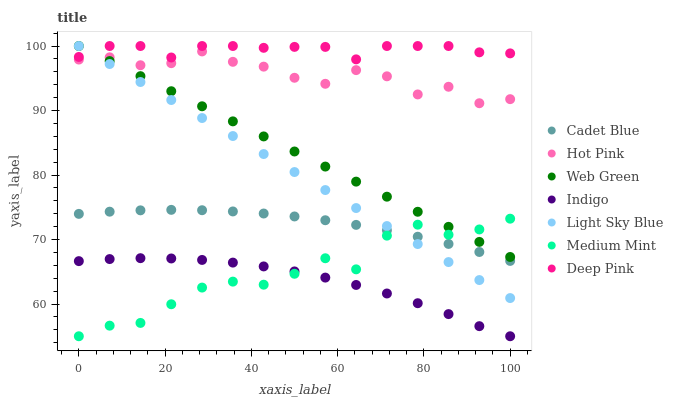Does Indigo have the minimum area under the curve?
Answer yes or no. Yes. Does Deep Pink have the maximum area under the curve?
Answer yes or no. Yes. Does Cadet Blue have the minimum area under the curve?
Answer yes or no. No. Does Cadet Blue have the maximum area under the curve?
Answer yes or no. No. Is Web Green the smoothest?
Answer yes or no. Yes. Is Medium Mint the roughest?
Answer yes or no. Yes. Is Cadet Blue the smoothest?
Answer yes or no. No. Is Cadet Blue the roughest?
Answer yes or no. No. Does Medium Mint have the lowest value?
Answer yes or no. Yes. Does Cadet Blue have the lowest value?
Answer yes or no. No. Does Light Sky Blue have the highest value?
Answer yes or no. Yes. Does Cadet Blue have the highest value?
Answer yes or no. No. Is Indigo less than Hot Pink?
Answer yes or no. Yes. Is Cadet Blue greater than Indigo?
Answer yes or no. Yes. Does Cadet Blue intersect Light Sky Blue?
Answer yes or no. Yes. Is Cadet Blue less than Light Sky Blue?
Answer yes or no. No. Is Cadet Blue greater than Light Sky Blue?
Answer yes or no. No. Does Indigo intersect Hot Pink?
Answer yes or no. No. 